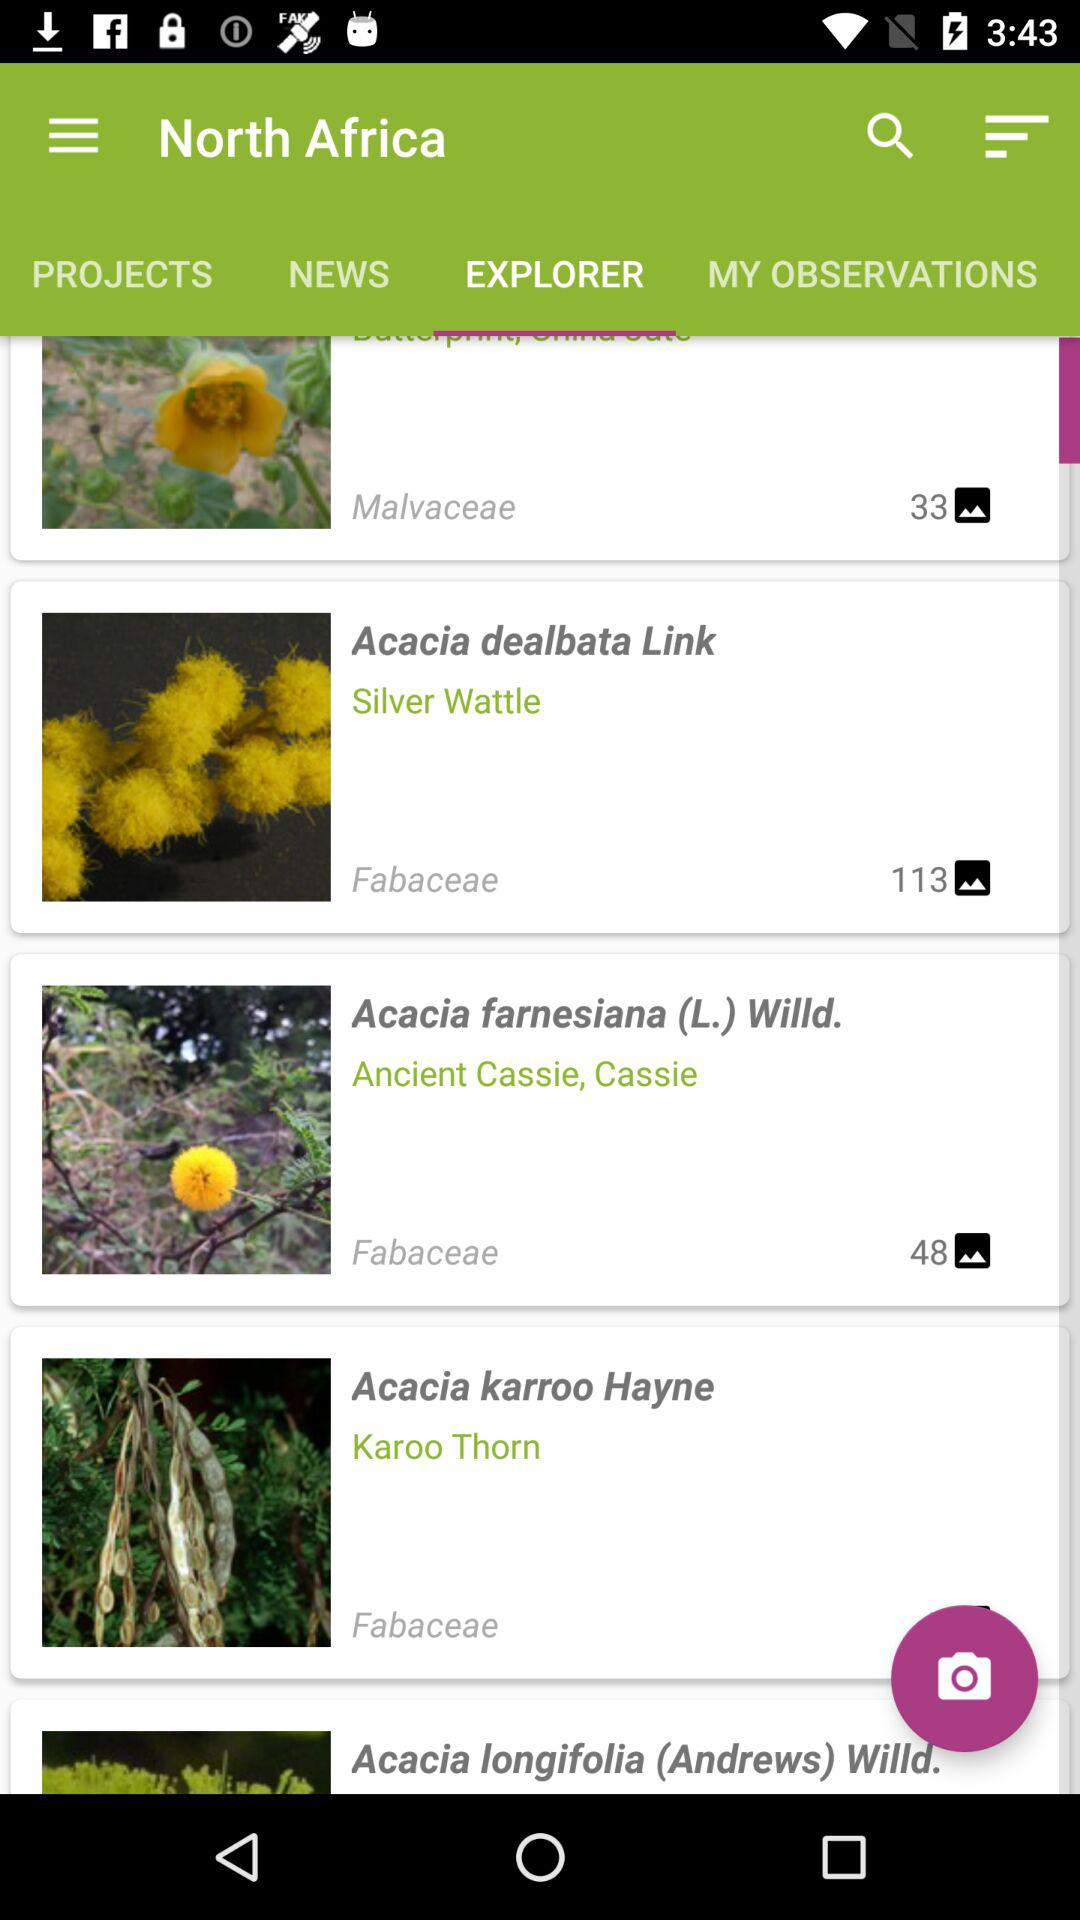How many Acacia karroo Hayne photos are there?
When the provided information is insufficient, respond with <no answer>. <no answer> 